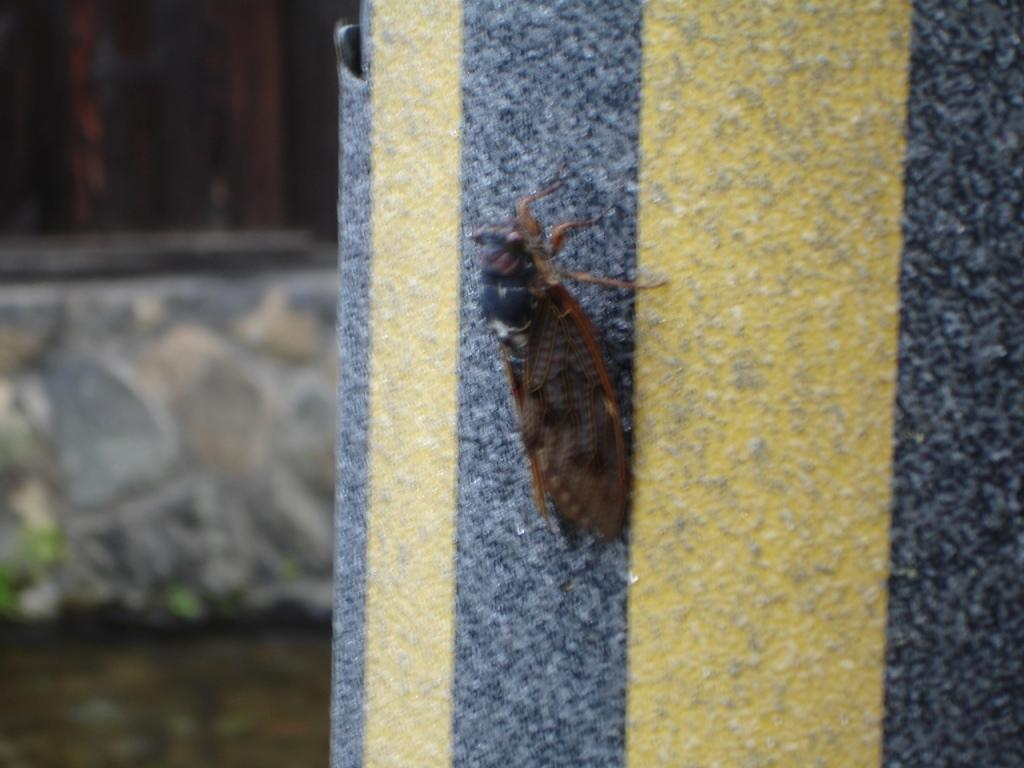What is present on the wall in the image? There is an insect on the wall in the image. Can you describe the background of the image? The background of the image is blurry. What type of heart can be seen beating on the stage in the image? There is no heart or stage present in the image; it only features an insect on the wall and a blurry background. 